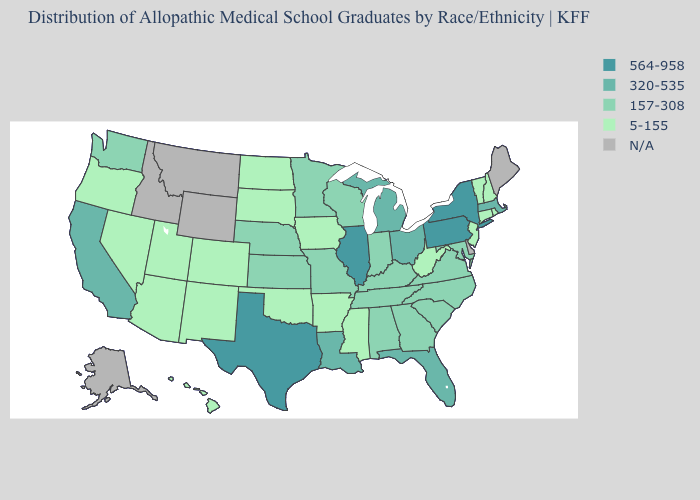Does the first symbol in the legend represent the smallest category?
Concise answer only. No. What is the highest value in the South ?
Quick response, please. 564-958. What is the value of Virginia?
Write a very short answer. 157-308. What is the value of Michigan?
Quick response, please. 320-535. What is the value of Maine?
Quick response, please. N/A. Which states have the highest value in the USA?
Concise answer only. Illinois, New York, Pennsylvania, Texas. How many symbols are there in the legend?
Answer briefly. 5. What is the highest value in the MidWest ?
Short answer required. 564-958. Does Michigan have the lowest value in the USA?
Give a very brief answer. No. What is the highest value in states that border Washington?
Write a very short answer. 5-155. What is the value of New Jersey?
Short answer required. 5-155. Which states have the lowest value in the Northeast?
Quick response, please. Connecticut, New Hampshire, New Jersey, Rhode Island, Vermont. Name the states that have a value in the range N/A?
Concise answer only. Alaska, Delaware, Idaho, Maine, Montana, Wyoming. What is the value of Maine?
Answer briefly. N/A. 